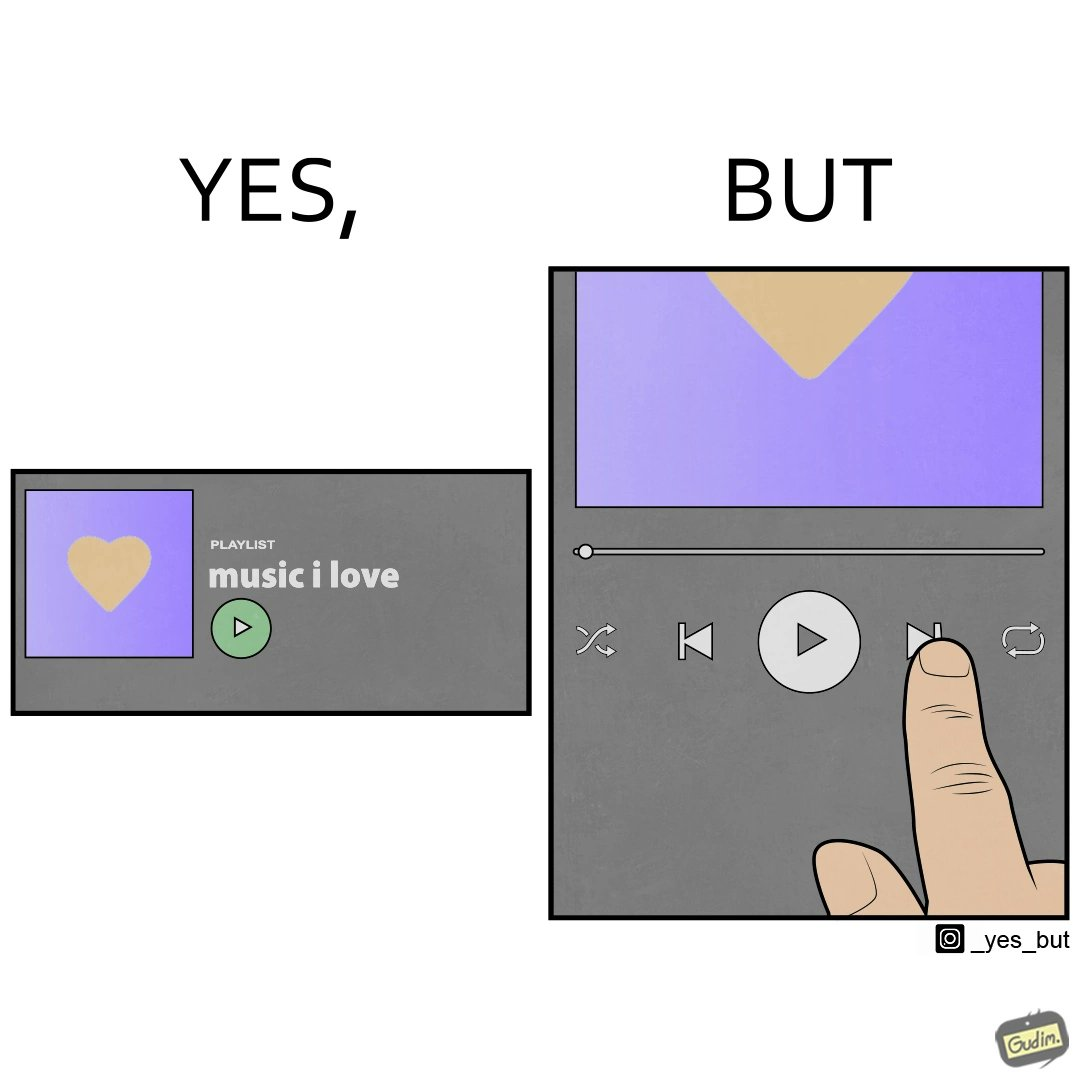Describe the content of this image. The image is funny because while the playlist is labelled "music I love" indicating that all the music in the playlist is very well liked by the user but the user is pressing play next button after listening to a few seconds of one of the audios in the playlist. 